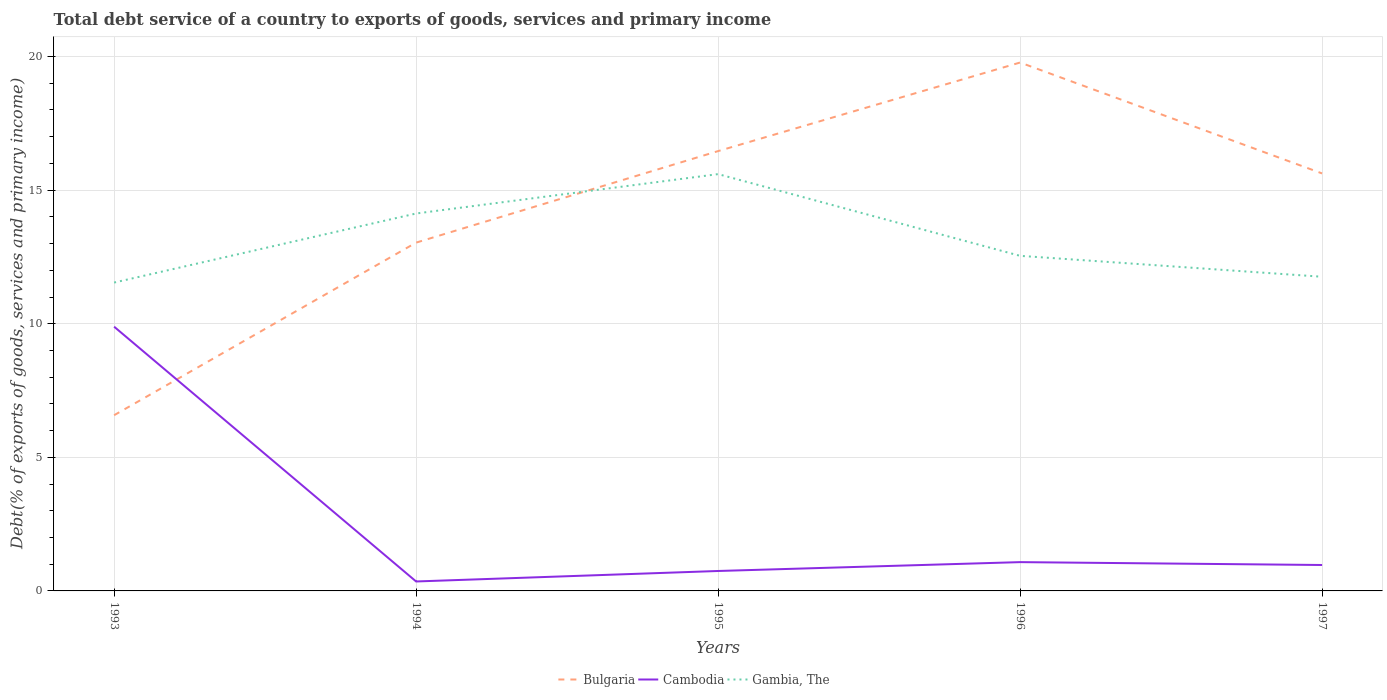How many different coloured lines are there?
Make the answer very short. 3. Does the line corresponding to Cambodia intersect with the line corresponding to Gambia, The?
Give a very brief answer. No. Is the number of lines equal to the number of legend labels?
Offer a terse response. Yes. Across all years, what is the maximum total debt service in Cambodia?
Your answer should be compact. 0.35. What is the total total debt service in Cambodia in the graph?
Offer a very short reply. -0.39. What is the difference between the highest and the second highest total debt service in Bulgaria?
Give a very brief answer. 13.2. What is the difference between the highest and the lowest total debt service in Bulgaria?
Your response must be concise. 3. Is the total debt service in Cambodia strictly greater than the total debt service in Bulgaria over the years?
Offer a very short reply. No. How many lines are there?
Keep it short and to the point. 3. What is the difference between two consecutive major ticks on the Y-axis?
Make the answer very short. 5. Are the values on the major ticks of Y-axis written in scientific E-notation?
Give a very brief answer. No. Does the graph contain any zero values?
Keep it short and to the point. No. Does the graph contain grids?
Offer a terse response. Yes. Where does the legend appear in the graph?
Your answer should be very brief. Bottom center. How many legend labels are there?
Make the answer very short. 3. What is the title of the graph?
Your response must be concise. Total debt service of a country to exports of goods, services and primary income. What is the label or title of the Y-axis?
Provide a succinct answer. Debt(% of exports of goods, services and primary income). What is the Debt(% of exports of goods, services and primary income) in Bulgaria in 1993?
Give a very brief answer. 6.58. What is the Debt(% of exports of goods, services and primary income) of Cambodia in 1993?
Your answer should be compact. 9.89. What is the Debt(% of exports of goods, services and primary income) of Gambia, The in 1993?
Offer a terse response. 11.54. What is the Debt(% of exports of goods, services and primary income) of Bulgaria in 1994?
Give a very brief answer. 13.04. What is the Debt(% of exports of goods, services and primary income) of Cambodia in 1994?
Your answer should be very brief. 0.35. What is the Debt(% of exports of goods, services and primary income) of Gambia, The in 1994?
Provide a succinct answer. 14.13. What is the Debt(% of exports of goods, services and primary income) of Bulgaria in 1995?
Your answer should be very brief. 16.46. What is the Debt(% of exports of goods, services and primary income) of Cambodia in 1995?
Give a very brief answer. 0.75. What is the Debt(% of exports of goods, services and primary income) of Gambia, The in 1995?
Keep it short and to the point. 15.6. What is the Debt(% of exports of goods, services and primary income) in Bulgaria in 1996?
Ensure brevity in your answer.  19.78. What is the Debt(% of exports of goods, services and primary income) in Cambodia in 1996?
Provide a succinct answer. 1.08. What is the Debt(% of exports of goods, services and primary income) in Gambia, The in 1996?
Your answer should be compact. 12.54. What is the Debt(% of exports of goods, services and primary income) in Bulgaria in 1997?
Your answer should be compact. 15.63. What is the Debt(% of exports of goods, services and primary income) in Cambodia in 1997?
Ensure brevity in your answer.  0.97. What is the Debt(% of exports of goods, services and primary income) in Gambia, The in 1997?
Your response must be concise. 11.76. Across all years, what is the maximum Debt(% of exports of goods, services and primary income) in Bulgaria?
Give a very brief answer. 19.78. Across all years, what is the maximum Debt(% of exports of goods, services and primary income) in Cambodia?
Your answer should be very brief. 9.89. Across all years, what is the maximum Debt(% of exports of goods, services and primary income) in Gambia, The?
Provide a succinct answer. 15.6. Across all years, what is the minimum Debt(% of exports of goods, services and primary income) in Bulgaria?
Your answer should be very brief. 6.58. Across all years, what is the minimum Debt(% of exports of goods, services and primary income) of Cambodia?
Offer a terse response. 0.35. Across all years, what is the minimum Debt(% of exports of goods, services and primary income) of Gambia, The?
Provide a succinct answer. 11.54. What is the total Debt(% of exports of goods, services and primary income) of Bulgaria in the graph?
Offer a terse response. 71.48. What is the total Debt(% of exports of goods, services and primary income) in Cambodia in the graph?
Your answer should be compact. 13.04. What is the total Debt(% of exports of goods, services and primary income) in Gambia, The in the graph?
Provide a succinct answer. 65.57. What is the difference between the Debt(% of exports of goods, services and primary income) of Bulgaria in 1993 and that in 1994?
Give a very brief answer. -6.46. What is the difference between the Debt(% of exports of goods, services and primary income) of Cambodia in 1993 and that in 1994?
Your answer should be compact. 9.54. What is the difference between the Debt(% of exports of goods, services and primary income) in Gambia, The in 1993 and that in 1994?
Offer a terse response. -2.58. What is the difference between the Debt(% of exports of goods, services and primary income) of Bulgaria in 1993 and that in 1995?
Provide a succinct answer. -9.89. What is the difference between the Debt(% of exports of goods, services and primary income) in Cambodia in 1993 and that in 1995?
Offer a terse response. 9.14. What is the difference between the Debt(% of exports of goods, services and primary income) of Gambia, The in 1993 and that in 1995?
Offer a terse response. -4.06. What is the difference between the Debt(% of exports of goods, services and primary income) of Bulgaria in 1993 and that in 1996?
Offer a terse response. -13.2. What is the difference between the Debt(% of exports of goods, services and primary income) of Cambodia in 1993 and that in 1996?
Provide a succinct answer. 8.81. What is the difference between the Debt(% of exports of goods, services and primary income) in Gambia, The in 1993 and that in 1996?
Give a very brief answer. -1. What is the difference between the Debt(% of exports of goods, services and primary income) of Bulgaria in 1993 and that in 1997?
Your response must be concise. -9.05. What is the difference between the Debt(% of exports of goods, services and primary income) in Cambodia in 1993 and that in 1997?
Give a very brief answer. 8.92. What is the difference between the Debt(% of exports of goods, services and primary income) in Gambia, The in 1993 and that in 1997?
Provide a short and direct response. -0.22. What is the difference between the Debt(% of exports of goods, services and primary income) of Bulgaria in 1994 and that in 1995?
Offer a terse response. -3.43. What is the difference between the Debt(% of exports of goods, services and primary income) of Cambodia in 1994 and that in 1995?
Provide a succinct answer. -0.39. What is the difference between the Debt(% of exports of goods, services and primary income) of Gambia, The in 1994 and that in 1995?
Provide a succinct answer. -1.47. What is the difference between the Debt(% of exports of goods, services and primary income) of Bulgaria in 1994 and that in 1996?
Provide a short and direct response. -6.74. What is the difference between the Debt(% of exports of goods, services and primary income) of Cambodia in 1994 and that in 1996?
Your answer should be compact. -0.72. What is the difference between the Debt(% of exports of goods, services and primary income) of Gambia, The in 1994 and that in 1996?
Provide a succinct answer. 1.58. What is the difference between the Debt(% of exports of goods, services and primary income) in Bulgaria in 1994 and that in 1997?
Offer a very short reply. -2.59. What is the difference between the Debt(% of exports of goods, services and primary income) of Cambodia in 1994 and that in 1997?
Your response must be concise. -0.62. What is the difference between the Debt(% of exports of goods, services and primary income) of Gambia, The in 1994 and that in 1997?
Your answer should be compact. 2.37. What is the difference between the Debt(% of exports of goods, services and primary income) in Bulgaria in 1995 and that in 1996?
Offer a terse response. -3.31. What is the difference between the Debt(% of exports of goods, services and primary income) in Cambodia in 1995 and that in 1996?
Your answer should be compact. -0.33. What is the difference between the Debt(% of exports of goods, services and primary income) in Gambia, The in 1995 and that in 1996?
Your answer should be compact. 3.06. What is the difference between the Debt(% of exports of goods, services and primary income) in Bulgaria in 1995 and that in 1997?
Make the answer very short. 0.84. What is the difference between the Debt(% of exports of goods, services and primary income) in Cambodia in 1995 and that in 1997?
Provide a succinct answer. -0.22. What is the difference between the Debt(% of exports of goods, services and primary income) of Gambia, The in 1995 and that in 1997?
Your answer should be compact. 3.84. What is the difference between the Debt(% of exports of goods, services and primary income) in Bulgaria in 1996 and that in 1997?
Ensure brevity in your answer.  4.15. What is the difference between the Debt(% of exports of goods, services and primary income) in Cambodia in 1996 and that in 1997?
Make the answer very short. 0.11. What is the difference between the Debt(% of exports of goods, services and primary income) in Gambia, The in 1996 and that in 1997?
Your answer should be compact. 0.78. What is the difference between the Debt(% of exports of goods, services and primary income) in Bulgaria in 1993 and the Debt(% of exports of goods, services and primary income) in Cambodia in 1994?
Keep it short and to the point. 6.22. What is the difference between the Debt(% of exports of goods, services and primary income) of Bulgaria in 1993 and the Debt(% of exports of goods, services and primary income) of Gambia, The in 1994?
Provide a short and direct response. -7.55. What is the difference between the Debt(% of exports of goods, services and primary income) of Cambodia in 1993 and the Debt(% of exports of goods, services and primary income) of Gambia, The in 1994?
Your answer should be compact. -4.24. What is the difference between the Debt(% of exports of goods, services and primary income) of Bulgaria in 1993 and the Debt(% of exports of goods, services and primary income) of Cambodia in 1995?
Provide a succinct answer. 5.83. What is the difference between the Debt(% of exports of goods, services and primary income) of Bulgaria in 1993 and the Debt(% of exports of goods, services and primary income) of Gambia, The in 1995?
Your answer should be compact. -9.02. What is the difference between the Debt(% of exports of goods, services and primary income) in Cambodia in 1993 and the Debt(% of exports of goods, services and primary income) in Gambia, The in 1995?
Give a very brief answer. -5.71. What is the difference between the Debt(% of exports of goods, services and primary income) of Bulgaria in 1993 and the Debt(% of exports of goods, services and primary income) of Cambodia in 1996?
Provide a short and direct response. 5.5. What is the difference between the Debt(% of exports of goods, services and primary income) in Bulgaria in 1993 and the Debt(% of exports of goods, services and primary income) in Gambia, The in 1996?
Provide a short and direct response. -5.97. What is the difference between the Debt(% of exports of goods, services and primary income) in Cambodia in 1993 and the Debt(% of exports of goods, services and primary income) in Gambia, The in 1996?
Your answer should be compact. -2.65. What is the difference between the Debt(% of exports of goods, services and primary income) of Bulgaria in 1993 and the Debt(% of exports of goods, services and primary income) of Cambodia in 1997?
Your response must be concise. 5.61. What is the difference between the Debt(% of exports of goods, services and primary income) in Bulgaria in 1993 and the Debt(% of exports of goods, services and primary income) in Gambia, The in 1997?
Keep it short and to the point. -5.18. What is the difference between the Debt(% of exports of goods, services and primary income) in Cambodia in 1993 and the Debt(% of exports of goods, services and primary income) in Gambia, The in 1997?
Offer a very short reply. -1.87. What is the difference between the Debt(% of exports of goods, services and primary income) in Bulgaria in 1994 and the Debt(% of exports of goods, services and primary income) in Cambodia in 1995?
Provide a succinct answer. 12.29. What is the difference between the Debt(% of exports of goods, services and primary income) in Bulgaria in 1994 and the Debt(% of exports of goods, services and primary income) in Gambia, The in 1995?
Provide a succinct answer. -2.56. What is the difference between the Debt(% of exports of goods, services and primary income) of Cambodia in 1994 and the Debt(% of exports of goods, services and primary income) of Gambia, The in 1995?
Ensure brevity in your answer.  -15.25. What is the difference between the Debt(% of exports of goods, services and primary income) in Bulgaria in 1994 and the Debt(% of exports of goods, services and primary income) in Cambodia in 1996?
Your response must be concise. 11.96. What is the difference between the Debt(% of exports of goods, services and primary income) in Bulgaria in 1994 and the Debt(% of exports of goods, services and primary income) in Gambia, The in 1996?
Give a very brief answer. 0.49. What is the difference between the Debt(% of exports of goods, services and primary income) in Cambodia in 1994 and the Debt(% of exports of goods, services and primary income) in Gambia, The in 1996?
Offer a very short reply. -12.19. What is the difference between the Debt(% of exports of goods, services and primary income) of Bulgaria in 1994 and the Debt(% of exports of goods, services and primary income) of Cambodia in 1997?
Offer a terse response. 12.07. What is the difference between the Debt(% of exports of goods, services and primary income) of Bulgaria in 1994 and the Debt(% of exports of goods, services and primary income) of Gambia, The in 1997?
Make the answer very short. 1.28. What is the difference between the Debt(% of exports of goods, services and primary income) in Cambodia in 1994 and the Debt(% of exports of goods, services and primary income) in Gambia, The in 1997?
Ensure brevity in your answer.  -11.4. What is the difference between the Debt(% of exports of goods, services and primary income) of Bulgaria in 1995 and the Debt(% of exports of goods, services and primary income) of Cambodia in 1996?
Your answer should be very brief. 15.38. What is the difference between the Debt(% of exports of goods, services and primary income) in Bulgaria in 1995 and the Debt(% of exports of goods, services and primary income) in Gambia, The in 1996?
Provide a short and direct response. 3.92. What is the difference between the Debt(% of exports of goods, services and primary income) of Cambodia in 1995 and the Debt(% of exports of goods, services and primary income) of Gambia, The in 1996?
Ensure brevity in your answer.  -11.79. What is the difference between the Debt(% of exports of goods, services and primary income) of Bulgaria in 1995 and the Debt(% of exports of goods, services and primary income) of Cambodia in 1997?
Offer a terse response. 15.49. What is the difference between the Debt(% of exports of goods, services and primary income) of Bulgaria in 1995 and the Debt(% of exports of goods, services and primary income) of Gambia, The in 1997?
Give a very brief answer. 4.7. What is the difference between the Debt(% of exports of goods, services and primary income) in Cambodia in 1995 and the Debt(% of exports of goods, services and primary income) in Gambia, The in 1997?
Make the answer very short. -11.01. What is the difference between the Debt(% of exports of goods, services and primary income) in Bulgaria in 1996 and the Debt(% of exports of goods, services and primary income) in Cambodia in 1997?
Keep it short and to the point. 18.81. What is the difference between the Debt(% of exports of goods, services and primary income) of Bulgaria in 1996 and the Debt(% of exports of goods, services and primary income) of Gambia, The in 1997?
Keep it short and to the point. 8.02. What is the difference between the Debt(% of exports of goods, services and primary income) of Cambodia in 1996 and the Debt(% of exports of goods, services and primary income) of Gambia, The in 1997?
Offer a terse response. -10.68. What is the average Debt(% of exports of goods, services and primary income) in Bulgaria per year?
Your answer should be very brief. 14.29. What is the average Debt(% of exports of goods, services and primary income) of Cambodia per year?
Provide a short and direct response. 2.61. What is the average Debt(% of exports of goods, services and primary income) in Gambia, The per year?
Your answer should be compact. 13.11. In the year 1993, what is the difference between the Debt(% of exports of goods, services and primary income) in Bulgaria and Debt(% of exports of goods, services and primary income) in Cambodia?
Give a very brief answer. -3.31. In the year 1993, what is the difference between the Debt(% of exports of goods, services and primary income) in Bulgaria and Debt(% of exports of goods, services and primary income) in Gambia, The?
Keep it short and to the point. -4.97. In the year 1993, what is the difference between the Debt(% of exports of goods, services and primary income) in Cambodia and Debt(% of exports of goods, services and primary income) in Gambia, The?
Keep it short and to the point. -1.65. In the year 1994, what is the difference between the Debt(% of exports of goods, services and primary income) of Bulgaria and Debt(% of exports of goods, services and primary income) of Cambodia?
Provide a short and direct response. 12.68. In the year 1994, what is the difference between the Debt(% of exports of goods, services and primary income) of Bulgaria and Debt(% of exports of goods, services and primary income) of Gambia, The?
Offer a terse response. -1.09. In the year 1994, what is the difference between the Debt(% of exports of goods, services and primary income) of Cambodia and Debt(% of exports of goods, services and primary income) of Gambia, The?
Keep it short and to the point. -13.77. In the year 1995, what is the difference between the Debt(% of exports of goods, services and primary income) of Bulgaria and Debt(% of exports of goods, services and primary income) of Cambodia?
Your response must be concise. 15.71. In the year 1995, what is the difference between the Debt(% of exports of goods, services and primary income) in Bulgaria and Debt(% of exports of goods, services and primary income) in Gambia, The?
Make the answer very short. 0.86. In the year 1995, what is the difference between the Debt(% of exports of goods, services and primary income) of Cambodia and Debt(% of exports of goods, services and primary income) of Gambia, The?
Give a very brief answer. -14.85. In the year 1996, what is the difference between the Debt(% of exports of goods, services and primary income) of Bulgaria and Debt(% of exports of goods, services and primary income) of Cambodia?
Provide a short and direct response. 18.7. In the year 1996, what is the difference between the Debt(% of exports of goods, services and primary income) in Bulgaria and Debt(% of exports of goods, services and primary income) in Gambia, The?
Provide a short and direct response. 7.24. In the year 1996, what is the difference between the Debt(% of exports of goods, services and primary income) in Cambodia and Debt(% of exports of goods, services and primary income) in Gambia, The?
Provide a short and direct response. -11.46. In the year 1997, what is the difference between the Debt(% of exports of goods, services and primary income) in Bulgaria and Debt(% of exports of goods, services and primary income) in Cambodia?
Offer a very short reply. 14.65. In the year 1997, what is the difference between the Debt(% of exports of goods, services and primary income) of Bulgaria and Debt(% of exports of goods, services and primary income) of Gambia, The?
Ensure brevity in your answer.  3.87. In the year 1997, what is the difference between the Debt(% of exports of goods, services and primary income) in Cambodia and Debt(% of exports of goods, services and primary income) in Gambia, The?
Provide a succinct answer. -10.79. What is the ratio of the Debt(% of exports of goods, services and primary income) in Bulgaria in 1993 to that in 1994?
Ensure brevity in your answer.  0.5. What is the ratio of the Debt(% of exports of goods, services and primary income) in Cambodia in 1993 to that in 1994?
Offer a terse response. 27.97. What is the ratio of the Debt(% of exports of goods, services and primary income) of Gambia, The in 1993 to that in 1994?
Your answer should be very brief. 0.82. What is the ratio of the Debt(% of exports of goods, services and primary income) of Bulgaria in 1993 to that in 1995?
Ensure brevity in your answer.  0.4. What is the ratio of the Debt(% of exports of goods, services and primary income) in Cambodia in 1993 to that in 1995?
Give a very brief answer. 13.25. What is the ratio of the Debt(% of exports of goods, services and primary income) in Gambia, The in 1993 to that in 1995?
Make the answer very short. 0.74. What is the ratio of the Debt(% of exports of goods, services and primary income) in Bulgaria in 1993 to that in 1996?
Your response must be concise. 0.33. What is the ratio of the Debt(% of exports of goods, services and primary income) of Cambodia in 1993 to that in 1996?
Offer a very short reply. 9.17. What is the ratio of the Debt(% of exports of goods, services and primary income) of Gambia, The in 1993 to that in 1996?
Your response must be concise. 0.92. What is the ratio of the Debt(% of exports of goods, services and primary income) of Bulgaria in 1993 to that in 1997?
Your response must be concise. 0.42. What is the ratio of the Debt(% of exports of goods, services and primary income) of Cambodia in 1993 to that in 1997?
Offer a terse response. 10.19. What is the ratio of the Debt(% of exports of goods, services and primary income) in Gambia, The in 1993 to that in 1997?
Your response must be concise. 0.98. What is the ratio of the Debt(% of exports of goods, services and primary income) in Bulgaria in 1994 to that in 1995?
Offer a terse response. 0.79. What is the ratio of the Debt(% of exports of goods, services and primary income) in Cambodia in 1994 to that in 1995?
Provide a short and direct response. 0.47. What is the ratio of the Debt(% of exports of goods, services and primary income) in Gambia, The in 1994 to that in 1995?
Provide a succinct answer. 0.91. What is the ratio of the Debt(% of exports of goods, services and primary income) in Bulgaria in 1994 to that in 1996?
Your response must be concise. 0.66. What is the ratio of the Debt(% of exports of goods, services and primary income) in Cambodia in 1994 to that in 1996?
Keep it short and to the point. 0.33. What is the ratio of the Debt(% of exports of goods, services and primary income) in Gambia, The in 1994 to that in 1996?
Ensure brevity in your answer.  1.13. What is the ratio of the Debt(% of exports of goods, services and primary income) of Bulgaria in 1994 to that in 1997?
Your answer should be compact. 0.83. What is the ratio of the Debt(% of exports of goods, services and primary income) of Cambodia in 1994 to that in 1997?
Provide a short and direct response. 0.36. What is the ratio of the Debt(% of exports of goods, services and primary income) of Gambia, The in 1994 to that in 1997?
Provide a succinct answer. 1.2. What is the ratio of the Debt(% of exports of goods, services and primary income) of Bulgaria in 1995 to that in 1996?
Your answer should be compact. 0.83. What is the ratio of the Debt(% of exports of goods, services and primary income) in Cambodia in 1995 to that in 1996?
Your answer should be compact. 0.69. What is the ratio of the Debt(% of exports of goods, services and primary income) in Gambia, The in 1995 to that in 1996?
Make the answer very short. 1.24. What is the ratio of the Debt(% of exports of goods, services and primary income) of Bulgaria in 1995 to that in 1997?
Provide a short and direct response. 1.05. What is the ratio of the Debt(% of exports of goods, services and primary income) in Cambodia in 1995 to that in 1997?
Your answer should be compact. 0.77. What is the ratio of the Debt(% of exports of goods, services and primary income) of Gambia, The in 1995 to that in 1997?
Your response must be concise. 1.33. What is the ratio of the Debt(% of exports of goods, services and primary income) of Bulgaria in 1996 to that in 1997?
Provide a short and direct response. 1.27. What is the ratio of the Debt(% of exports of goods, services and primary income) of Cambodia in 1996 to that in 1997?
Provide a succinct answer. 1.11. What is the ratio of the Debt(% of exports of goods, services and primary income) of Gambia, The in 1996 to that in 1997?
Ensure brevity in your answer.  1.07. What is the difference between the highest and the second highest Debt(% of exports of goods, services and primary income) in Bulgaria?
Give a very brief answer. 3.31. What is the difference between the highest and the second highest Debt(% of exports of goods, services and primary income) of Cambodia?
Your answer should be compact. 8.81. What is the difference between the highest and the second highest Debt(% of exports of goods, services and primary income) of Gambia, The?
Your answer should be compact. 1.47. What is the difference between the highest and the lowest Debt(% of exports of goods, services and primary income) of Bulgaria?
Your answer should be compact. 13.2. What is the difference between the highest and the lowest Debt(% of exports of goods, services and primary income) of Cambodia?
Offer a very short reply. 9.54. What is the difference between the highest and the lowest Debt(% of exports of goods, services and primary income) in Gambia, The?
Provide a short and direct response. 4.06. 